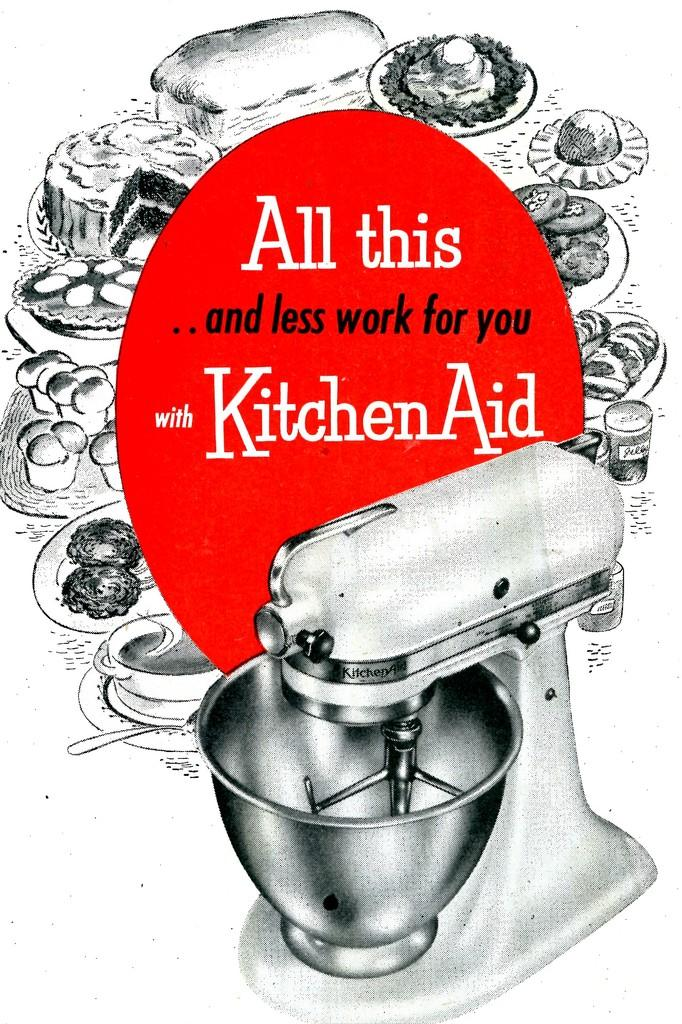<image>
Give a short and clear explanation of the subsequent image. an ad poster that says 'all this...and less work for you with kitchen aid' 